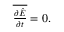Convert formula to latex. <formula><loc_0><loc_0><loc_500><loc_500>\begin{array} { r } { \overline { { \frac { \partial \hat { E } } { \partial t } } } = 0 . } \end{array}</formula> 